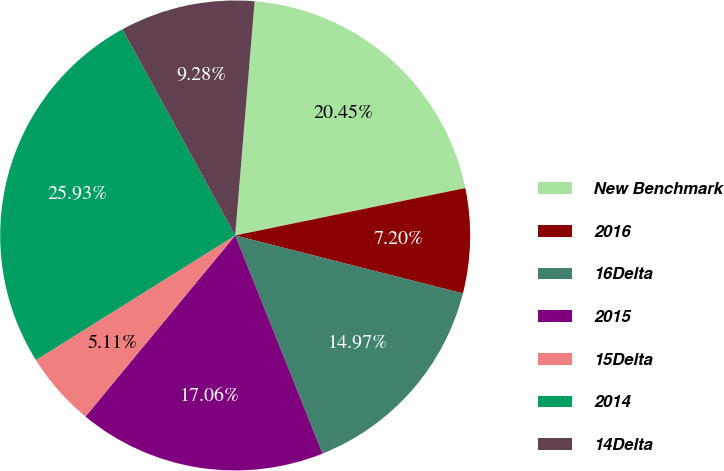Convert chart to OTSL. <chart><loc_0><loc_0><loc_500><loc_500><pie_chart><fcel>New Benchmark<fcel>2016<fcel>16Delta<fcel>2015<fcel>15Delta<fcel>2014<fcel>14Delta<nl><fcel>20.45%<fcel>7.2%<fcel>14.97%<fcel>17.06%<fcel>5.11%<fcel>25.93%<fcel>9.28%<nl></chart> 